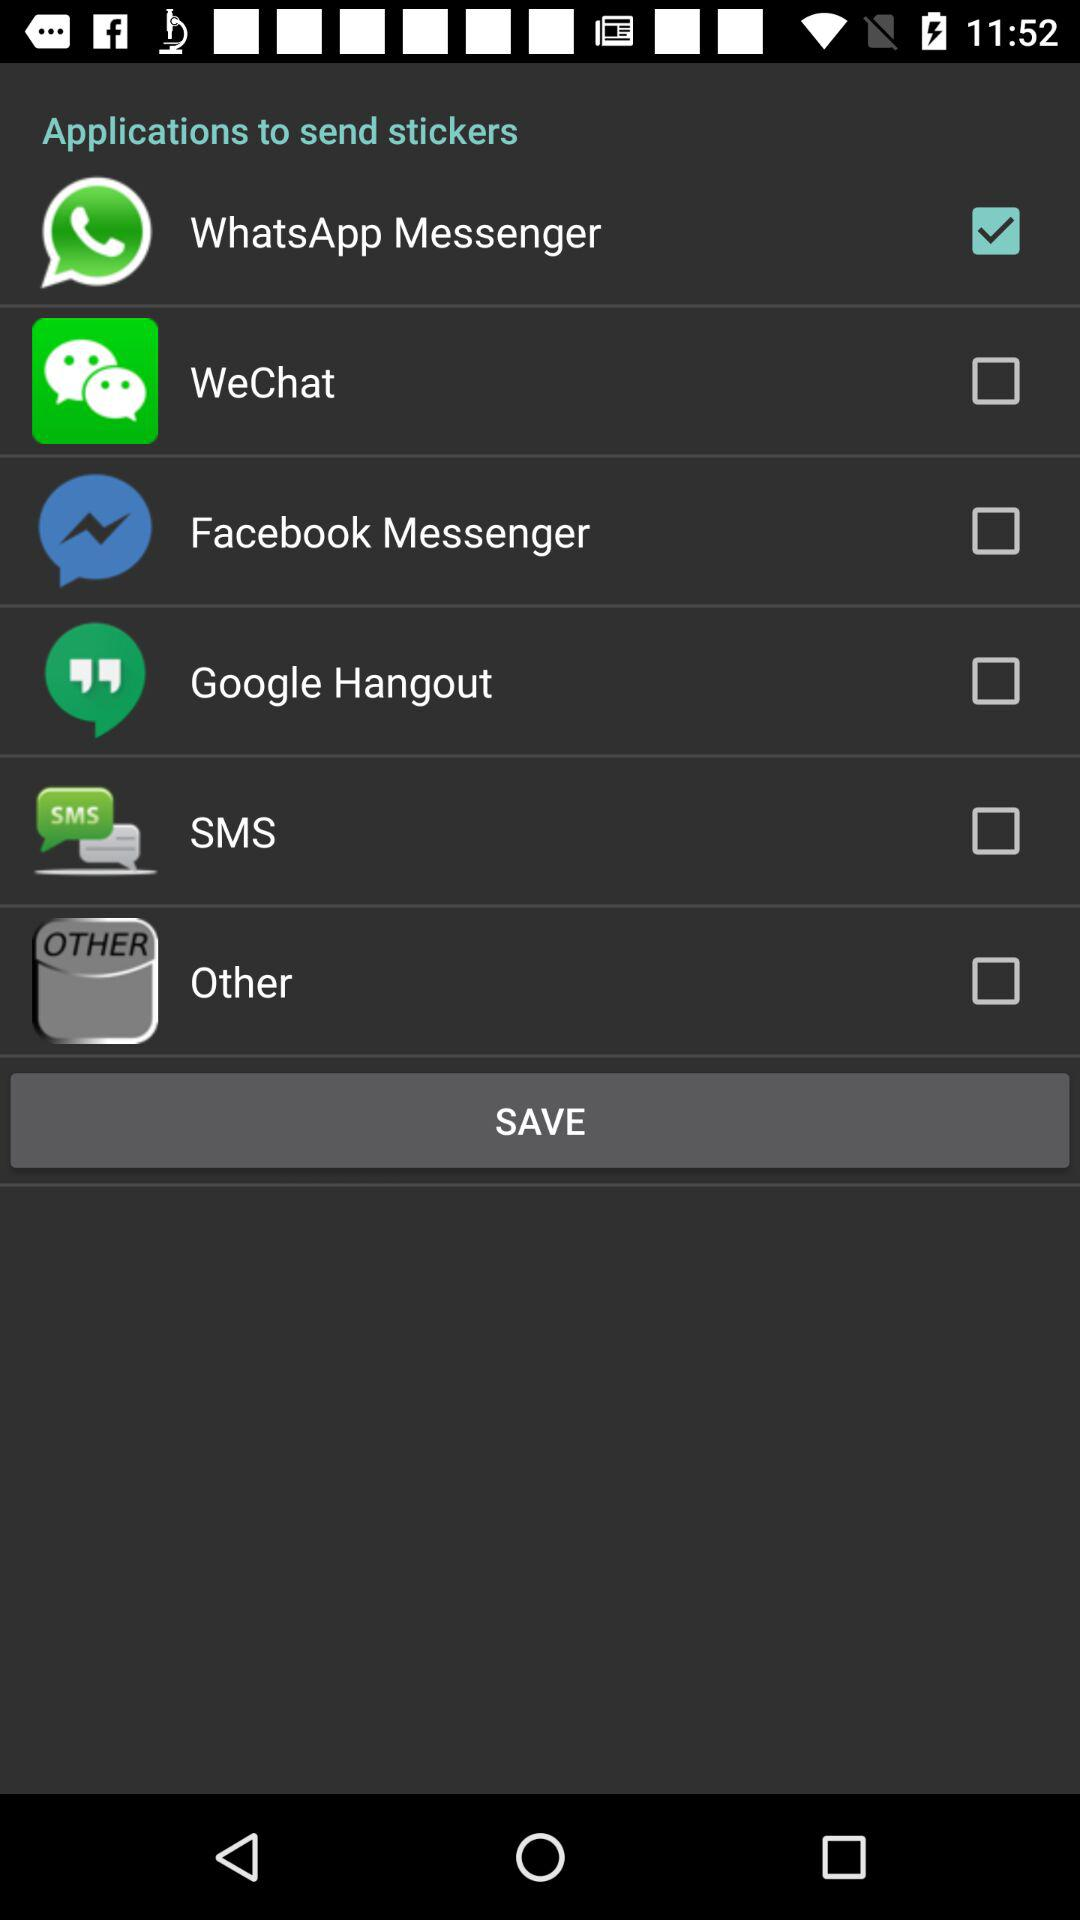Which applications is selected? The selected application is "WhatsApp Messenger". 